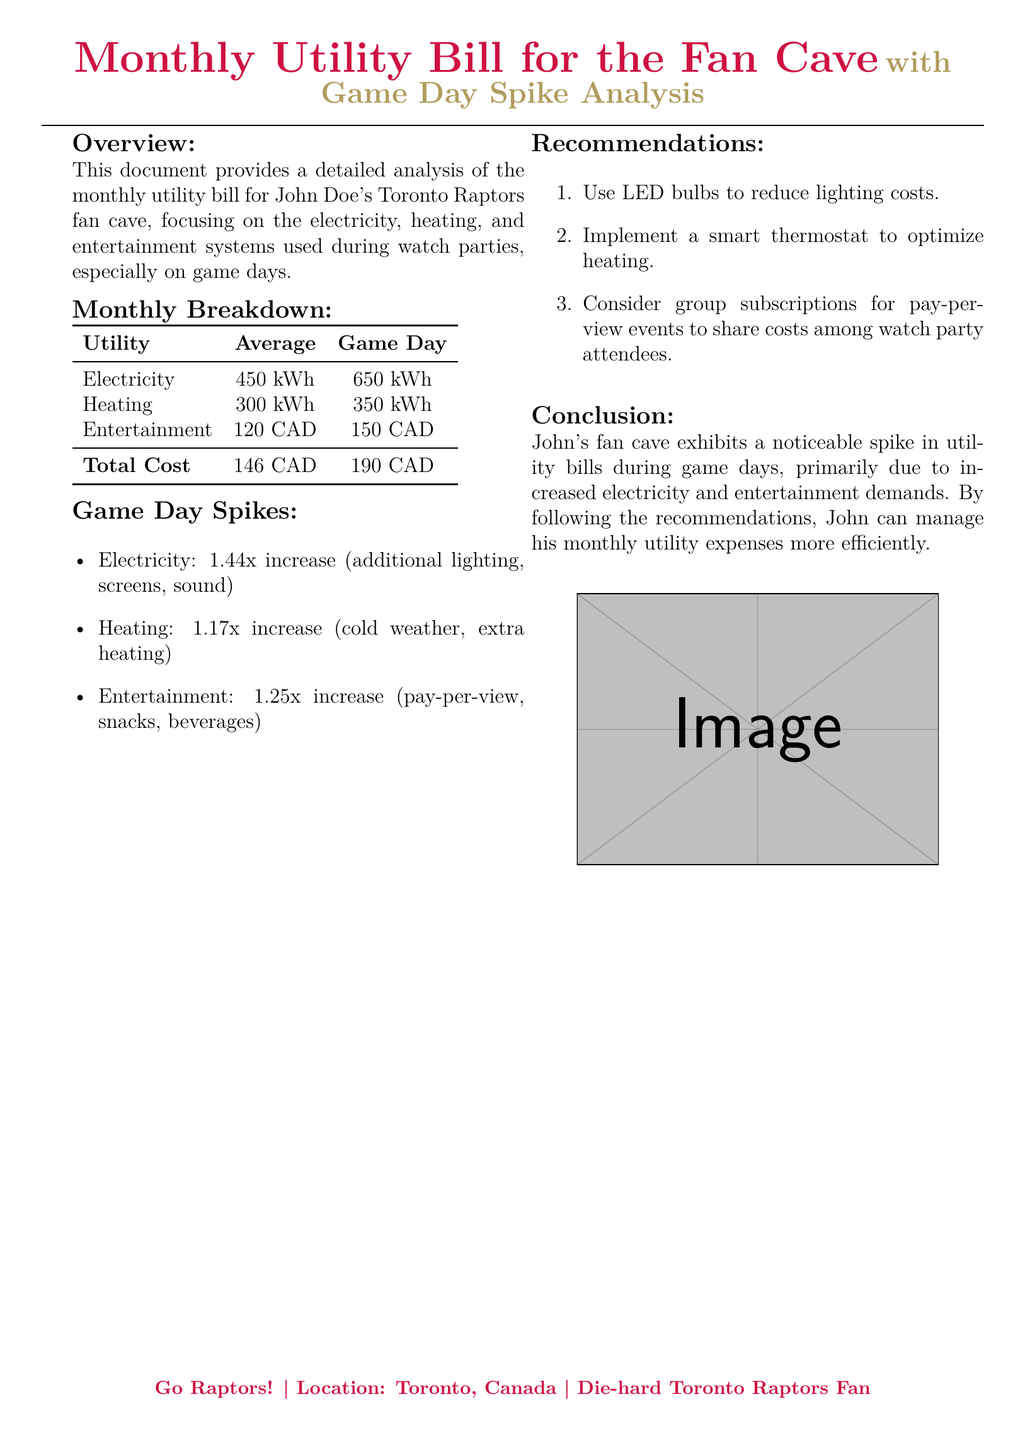What is the average monthly electricity consumption? The average monthly electricity consumption is found in the table under the 'Average' column for electricity.
Answer: 450 kWh What is the total cost on game day? The total cost on game day is located in the table under the 'Game Day' column for total cost.
Answer: 190 CAD What is the increase factor for entertainment costs on game days? The increase factor is specified in the game day spikes section where entertainment is discussed.
Answer: 1.25x How much electricity is consumed on game days? The game day electricity consumption is provided in the monthly breakdown table under the 'Game Day' column for electricity.
Answer: 650 kWh What does John plan to implement to optimize heating? The recommendation suggests a specific action for optimizing heating mentioned in the recommendations section.
Answer: Smart thermostat What is the average heating consumption? The average heating consumption is referenced in the table under the 'Average' column for heating.
Answer: 300 kWh How much additional electricity is used during game days? The additional electricity usage is described as a percentage increase in the game day spikes section for electricity.
Answer: 1.44x What are the recommended changes to reduce lighting costs? The recommendation section includes an actionable item related to lighting costs.
Answer: Use LED bulbs What is the average monthly entertainment cost? The average monthly entertainment cost is located in the table under the 'Average' column for entertainment.
Answer: 120 CAD 